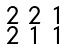Convert formula to latex. <formula><loc_0><loc_0><loc_500><loc_500>\begin{smallmatrix} 2 & 2 & 1 \\ 2 & 1 & 1 \end{smallmatrix}</formula> 